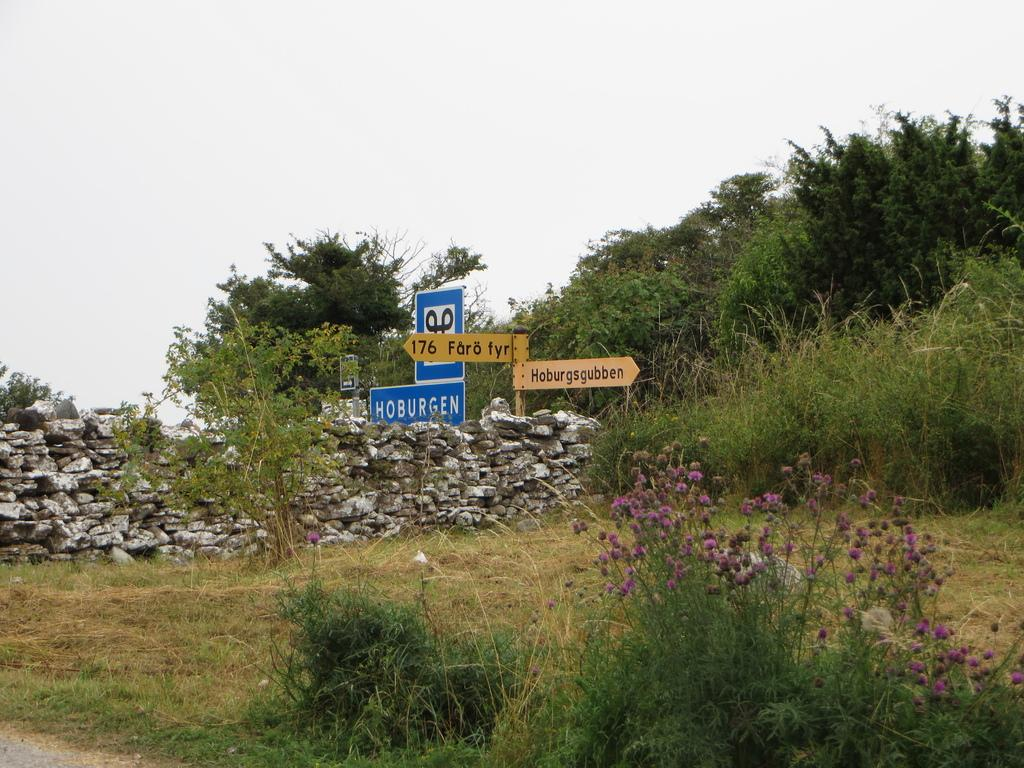What can be seen on the sign boards in the image? The specific content of the sign boards cannot be determined from the image. What type of small stones are present in the image? There are pebbles in the image. Where are the sign boards and pebbles located in the image? The center of the image contains sign boards and pebbles. What type of vegetation is visible in the image? There is greenery in the image. What type of belief is represented by the cars in the image? There are no cars present in the image, so it is not possible to determine any beliefs related to them. 